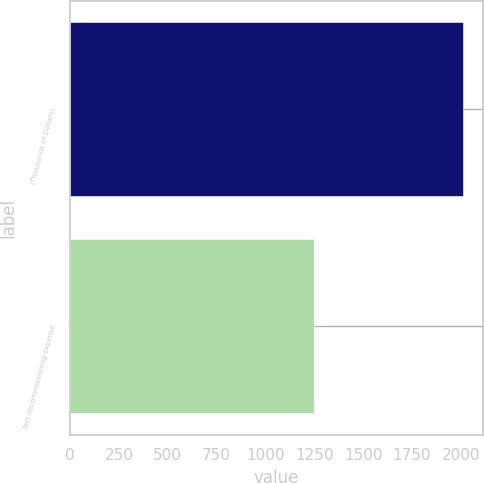<chart> <loc_0><loc_0><loc_500><loc_500><bar_chart><fcel>(Thousands of Dollars)<fcel>Net decommissioning expense<nl><fcel>2012<fcel>1251<nl></chart> 